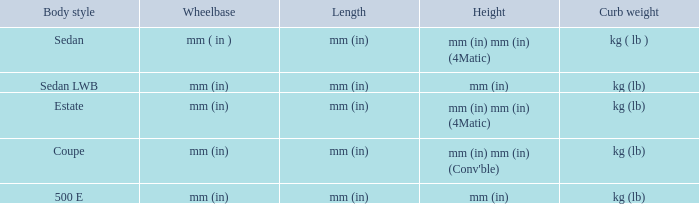What are the lengths of the models that are mm (in) tall? Mm (in), mm (in). 